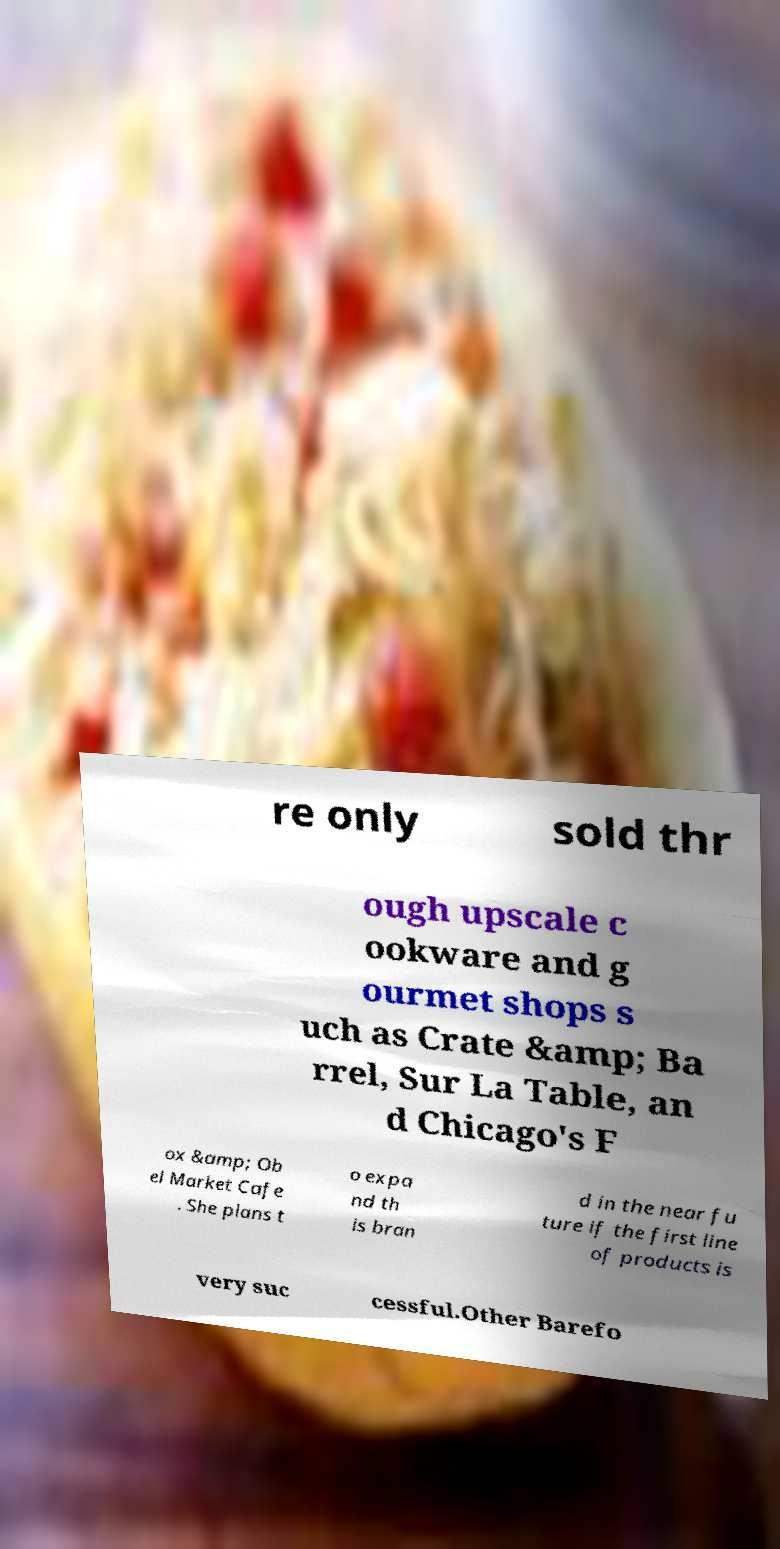Please read and relay the text visible in this image. What does it say? re only sold thr ough upscale c ookware and g ourmet shops s uch as Crate &amp; Ba rrel, Sur La Table, an d Chicago's F ox &amp; Ob el Market Cafe . She plans t o expa nd th is bran d in the near fu ture if the first line of products is very suc cessful.Other Barefo 